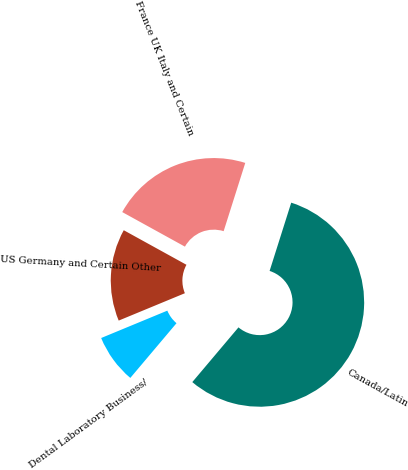<chart> <loc_0><loc_0><loc_500><loc_500><pie_chart><fcel>US Germany and Certain Other<fcel>France UK Italy and Certain<fcel>Canada/Latin<fcel>Dental Laboratory Business/<nl><fcel>14.26%<fcel>21.86%<fcel>56.27%<fcel>7.6%<nl></chart> 